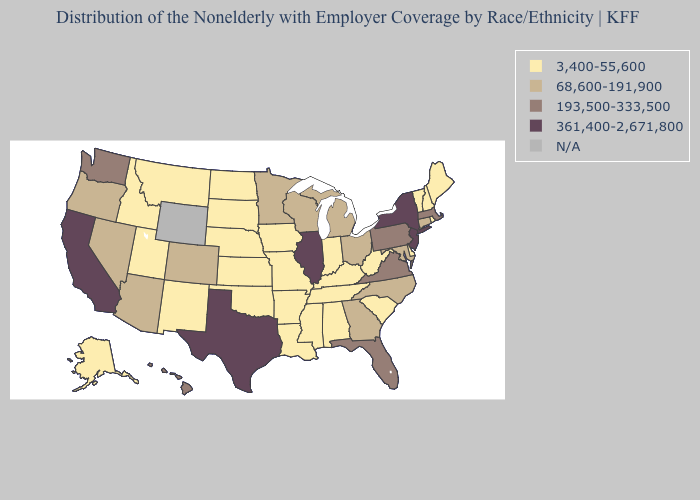What is the highest value in the South ?
Give a very brief answer. 361,400-2,671,800. Which states hav the highest value in the West?
Give a very brief answer. California. What is the highest value in the USA?
Answer briefly. 361,400-2,671,800. Name the states that have a value in the range 193,500-333,500?
Give a very brief answer. Florida, Hawaii, Massachusetts, Pennsylvania, Virginia, Washington. Which states have the lowest value in the USA?
Write a very short answer. Alabama, Alaska, Arkansas, Delaware, Idaho, Indiana, Iowa, Kansas, Kentucky, Louisiana, Maine, Mississippi, Missouri, Montana, Nebraska, New Hampshire, New Mexico, North Dakota, Oklahoma, Rhode Island, South Carolina, South Dakota, Tennessee, Utah, Vermont, West Virginia. What is the lowest value in the USA?
Be succinct. 3,400-55,600. Does Alaska have the highest value in the USA?
Short answer required. No. What is the value of Illinois?
Give a very brief answer. 361,400-2,671,800. Name the states that have a value in the range N/A?
Answer briefly. Wyoming. Which states have the lowest value in the Northeast?
Write a very short answer. Maine, New Hampshire, Rhode Island, Vermont. 